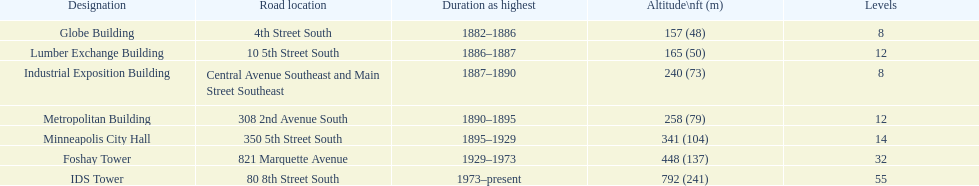Name the tallest building. IDS Tower. 